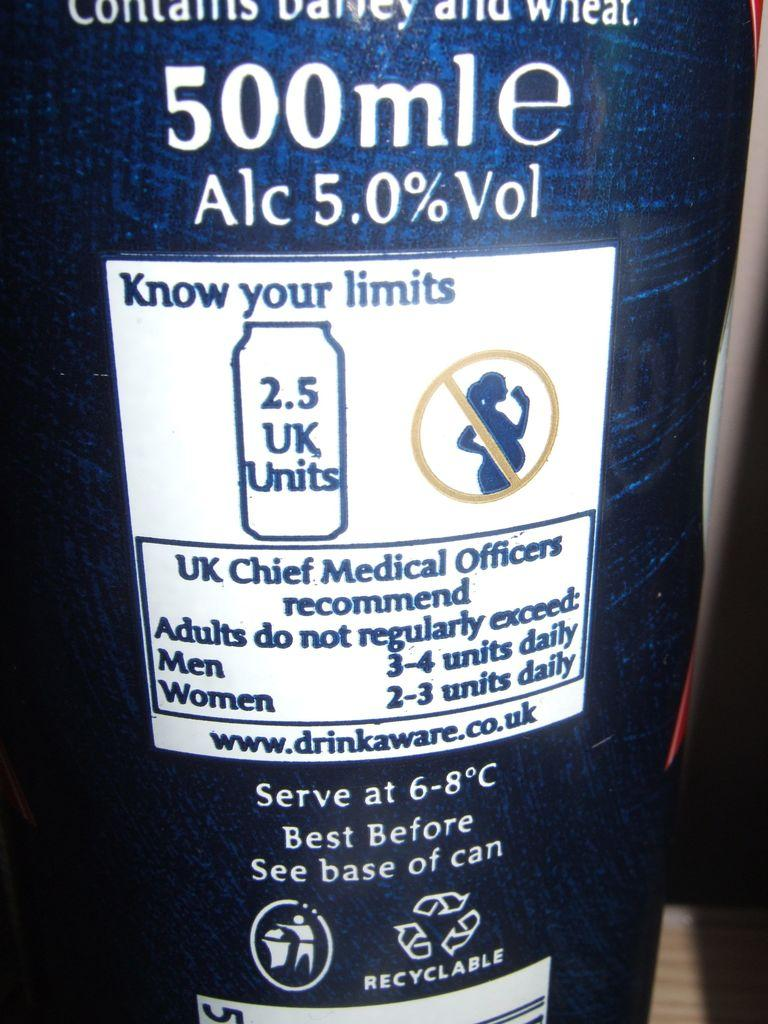<image>
Create a compact narrative representing the image presented. A safety label on the back of a bottle of beer with a UK Medical Officers recommendation of how much to drink. 